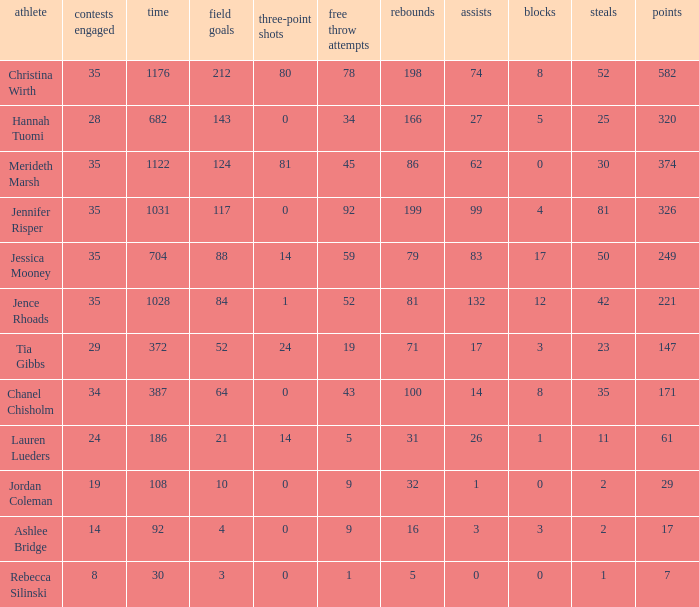How much time, in minutes, did Chanel Chisholm play? 1.0. 